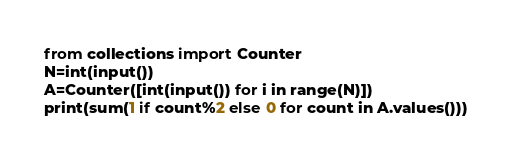Convert code to text. <code><loc_0><loc_0><loc_500><loc_500><_Python_>from collections import Counter
N=int(input())
A=Counter([int(input()) for i in range(N)])
print(sum(1 if count%2 else 0 for count in A.values()))</code> 